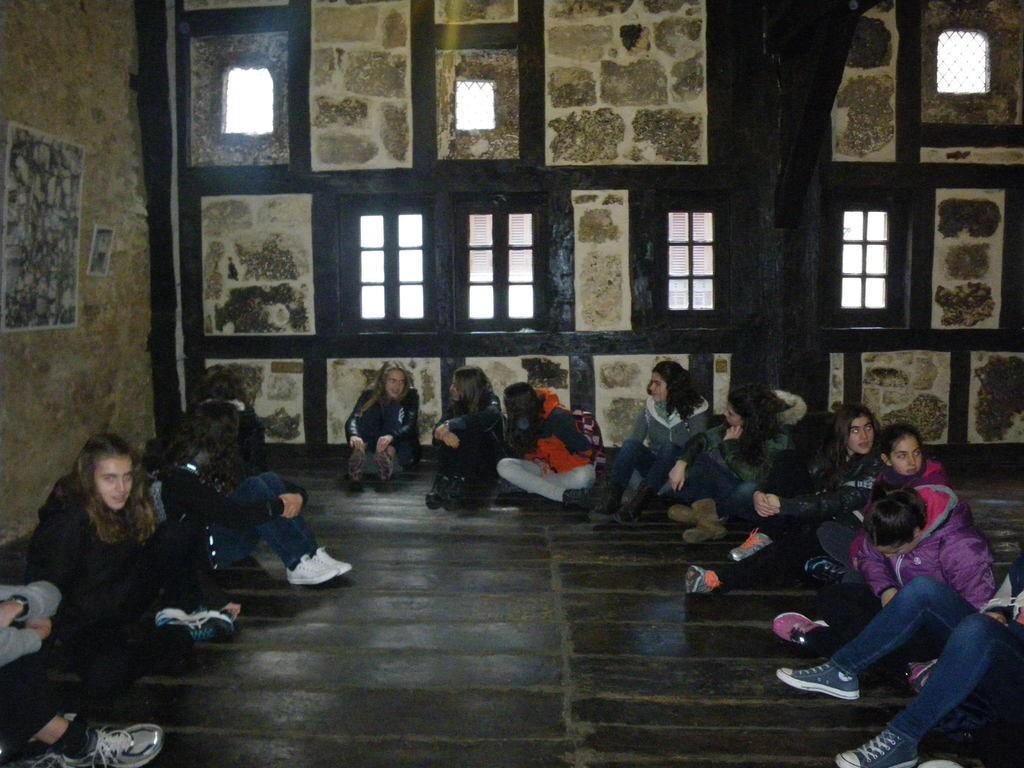Can you describe this image briefly? In this image I can see there are few person sitting on the floor and at the top I can see the wall and the window. 